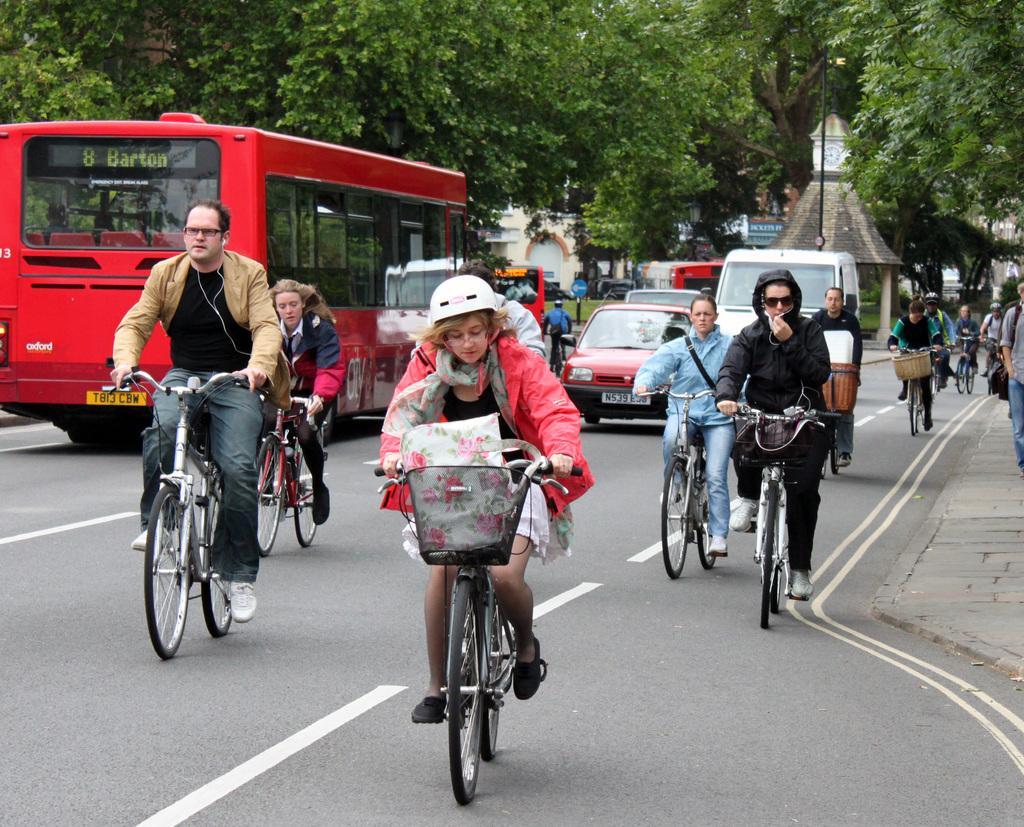Could you give a brief overview of what you see in this image? In this image i can see few people riding their bicycles and few other vehicles. In the background i can see few trees, buildings and the road. 